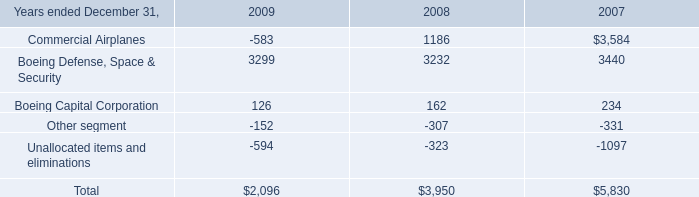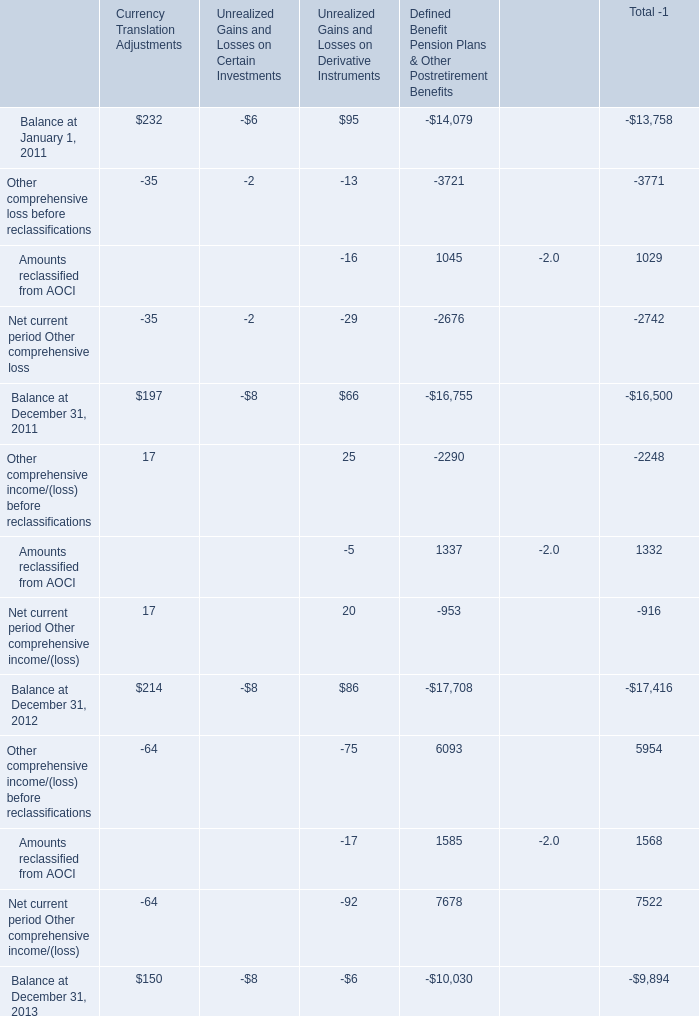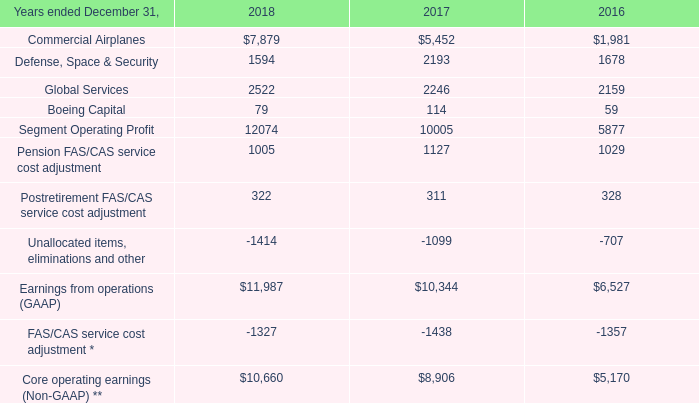In the year with largest amount of Currency Translation Adjustments, what's the increasing rate of Unrealized Gains and Losses on Derivative Instruments? 
Computations: ((86 - 66) / 66)
Answer: 0.30303. 